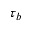Convert formula to latex. <formula><loc_0><loc_0><loc_500><loc_500>\tau _ { b }</formula> 